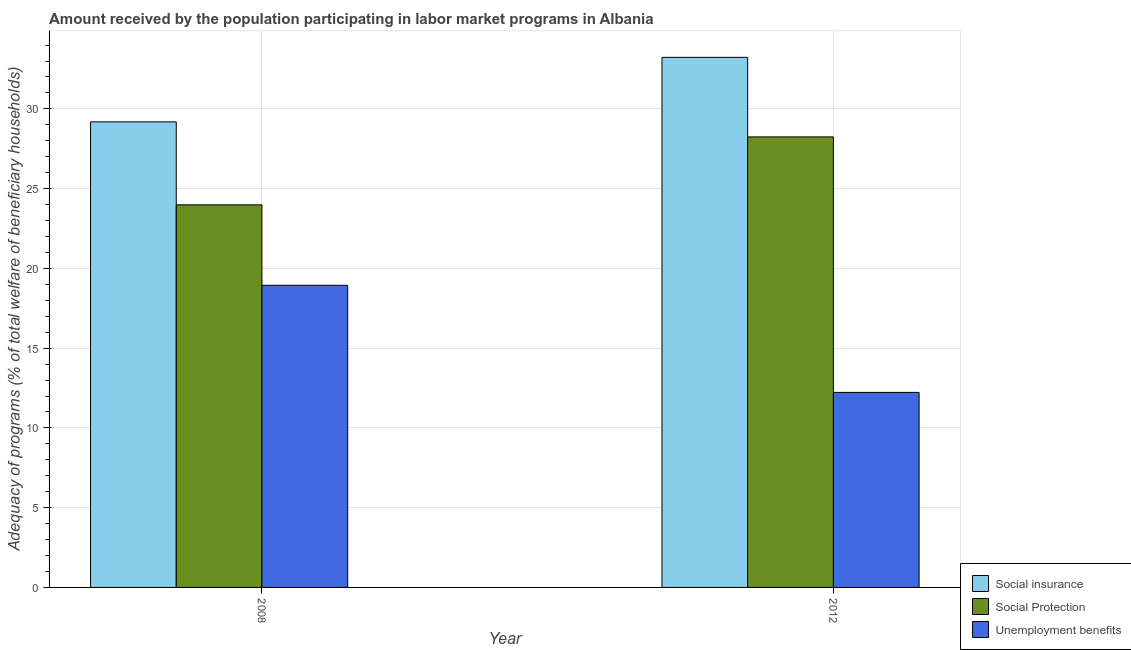How many groups of bars are there?
Provide a short and direct response. 2. Are the number of bars per tick equal to the number of legend labels?
Your answer should be compact. Yes. Are the number of bars on each tick of the X-axis equal?
Offer a very short reply. Yes. How many bars are there on the 1st tick from the right?
Make the answer very short. 3. What is the label of the 1st group of bars from the left?
Your answer should be very brief. 2008. What is the amount received by the population participating in social insurance programs in 2008?
Make the answer very short. 29.19. Across all years, what is the maximum amount received by the population participating in unemployment benefits programs?
Ensure brevity in your answer.  18.94. Across all years, what is the minimum amount received by the population participating in social insurance programs?
Make the answer very short. 29.19. What is the total amount received by the population participating in social protection programs in the graph?
Provide a short and direct response. 52.23. What is the difference between the amount received by the population participating in unemployment benefits programs in 2008 and that in 2012?
Your response must be concise. 6.71. What is the difference between the amount received by the population participating in social insurance programs in 2008 and the amount received by the population participating in social protection programs in 2012?
Ensure brevity in your answer.  -4.05. What is the average amount received by the population participating in social protection programs per year?
Provide a short and direct response. 26.11. In the year 2008, what is the difference between the amount received by the population participating in social protection programs and amount received by the population participating in unemployment benefits programs?
Ensure brevity in your answer.  0. What is the ratio of the amount received by the population participating in unemployment benefits programs in 2008 to that in 2012?
Offer a terse response. 1.55. Is the amount received by the population participating in social protection programs in 2008 less than that in 2012?
Offer a very short reply. Yes. What does the 2nd bar from the left in 2012 represents?
Give a very brief answer. Social Protection. What does the 2nd bar from the right in 2012 represents?
Your response must be concise. Social Protection. Is it the case that in every year, the sum of the amount received by the population participating in social insurance programs and amount received by the population participating in social protection programs is greater than the amount received by the population participating in unemployment benefits programs?
Provide a succinct answer. Yes. What is the difference between two consecutive major ticks on the Y-axis?
Offer a terse response. 5. Does the graph contain grids?
Offer a terse response. Yes. How are the legend labels stacked?
Offer a very short reply. Vertical. What is the title of the graph?
Offer a very short reply. Amount received by the population participating in labor market programs in Albania. Does "Non-communicable diseases" appear as one of the legend labels in the graph?
Your answer should be very brief. No. What is the label or title of the X-axis?
Provide a short and direct response. Year. What is the label or title of the Y-axis?
Offer a very short reply. Adequacy of programs (% of total welfare of beneficiary households). What is the Adequacy of programs (% of total welfare of beneficiary households) in Social insurance in 2008?
Give a very brief answer. 29.19. What is the Adequacy of programs (% of total welfare of beneficiary households) in Social Protection in 2008?
Your answer should be compact. 23.99. What is the Adequacy of programs (% of total welfare of beneficiary households) in Unemployment benefits in 2008?
Your answer should be very brief. 18.94. What is the Adequacy of programs (% of total welfare of beneficiary households) of Social insurance in 2012?
Offer a terse response. 33.23. What is the Adequacy of programs (% of total welfare of beneficiary households) in Social Protection in 2012?
Make the answer very short. 28.24. What is the Adequacy of programs (% of total welfare of beneficiary households) of Unemployment benefits in 2012?
Keep it short and to the point. 12.23. Across all years, what is the maximum Adequacy of programs (% of total welfare of beneficiary households) in Social insurance?
Offer a terse response. 33.23. Across all years, what is the maximum Adequacy of programs (% of total welfare of beneficiary households) in Social Protection?
Offer a terse response. 28.24. Across all years, what is the maximum Adequacy of programs (% of total welfare of beneficiary households) in Unemployment benefits?
Offer a very short reply. 18.94. Across all years, what is the minimum Adequacy of programs (% of total welfare of beneficiary households) in Social insurance?
Keep it short and to the point. 29.19. Across all years, what is the minimum Adequacy of programs (% of total welfare of beneficiary households) of Social Protection?
Provide a short and direct response. 23.99. Across all years, what is the minimum Adequacy of programs (% of total welfare of beneficiary households) of Unemployment benefits?
Ensure brevity in your answer.  12.23. What is the total Adequacy of programs (% of total welfare of beneficiary households) of Social insurance in the graph?
Your answer should be compact. 62.42. What is the total Adequacy of programs (% of total welfare of beneficiary households) in Social Protection in the graph?
Provide a succinct answer. 52.23. What is the total Adequacy of programs (% of total welfare of beneficiary households) in Unemployment benefits in the graph?
Ensure brevity in your answer.  31.17. What is the difference between the Adequacy of programs (% of total welfare of beneficiary households) of Social insurance in 2008 and that in 2012?
Your response must be concise. -4.05. What is the difference between the Adequacy of programs (% of total welfare of beneficiary households) in Social Protection in 2008 and that in 2012?
Your response must be concise. -4.26. What is the difference between the Adequacy of programs (% of total welfare of beneficiary households) in Unemployment benefits in 2008 and that in 2012?
Ensure brevity in your answer.  6.71. What is the difference between the Adequacy of programs (% of total welfare of beneficiary households) in Social insurance in 2008 and the Adequacy of programs (% of total welfare of beneficiary households) in Social Protection in 2012?
Keep it short and to the point. 0.94. What is the difference between the Adequacy of programs (% of total welfare of beneficiary households) of Social insurance in 2008 and the Adequacy of programs (% of total welfare of beneficiary households) of Unemployment benefits in 2012?
Give a very brief answer. 16.96. What is the difference between the Adequacy of programs (% of total welfare of beneficiary households) of Social Protection in 2008 and the Adequacy of programs (% of total welfare of beneficiary households) of Unemployment benefits in 2012?
Your response must be concise. 11.76. What is the average Adequacy of programs (% of total welfare of beneficiary households) of Social insurance per year?
Your answer should be compact. 31.21. What is the average Adequacy of programs (% of total welfare of beneficiary households) of Social Protection per year?
Your answer should be compact. 26.11. What is the average Adequacy of programs (% of total welfare of beneficiary households) in Unemployment benefits per year?
Your answer should be very brief. 15.58. In the year 2008, what is the difference between the Adequacy of programs (% of total welfare of beneficiary households) in Social insurance and Adequacy of programs (% of total welfare of beneficiary households) in Social Protection?
Make the answer very short. 5.2. In the year 2008, what is the difference between the Adequacy of programs (% of total welfare of beneficiary households) in Social insurance and Adequacy of programs (% of total welfare of beneficiary households) in Unemployment benefits?
Offer a very short reply. 10.24. In the year 2008, what is the difference between the Adequacy of programs (% of total welfare of beneficiary households) of Social Protection and Adequacy of programs (% of total welfare of beneficiary households) of Unemployment benefits?
Offer a very short reply. 5.04. In the year 2012, what is the difference between the Adequacy of programs (% of total welfare of beneficiary households) of Social insurance and Adequacy of programs (% of total welfare of beneficiary households) of Social Protection?
Make the answer very short. 4.99. In the year 2012, what is the difference between the Adequacy of programs (% of total welfare of beneficiary households) in Social insurance and Adequacy of programs (% of total welfare of beneficiary households) in Unemployment benefits?
Ensure brevity in your answer.  21.01. In the year 2012, what is the difference between the Adequacy of programs (% of total welfare of beneficiary households) of Social Protection and Adequacy of programs (% of total welfare of beneficiary households) of Unemployment benefits?
Your answer should be compact. 16.02. What is the ratio of the Adequacy of programs (% of total welfare of beneficiary households) in Social insurance in 2008 to that in 2012?
Your answer should be very brief. 0.88. What is the ratio of the Adequacy of programs (% of total welfare of beneficiary households) in Social Protection in 2008 to that in 2012?
Ensure brevity in your answer.  0.85. What is the ratio of the Adequacy of programs (% of total welfare of beneficiary households) in Unemployment benefits in 2008 to that in 2012?
Provide a succinct answer. 1.55. What is the difference between the highest and the second highest Adequacy of programs (% of total welfare of beneficiary households) of Social insurance?
Keep it short and to the point. 4.05. What is the difference between the highest and the second highest Adequacy of programs (% of total welfare of beneficiary households) of Social Protection?
Give a very brief answer. 4.26. What is the difference between the highest and the second highest Adequacy of programs (% of total welfare of beneficiary households) of Unemployment benefits?
Give a very brief answer. 6.71. What is the difference between the highest and the lowest Adequacy of programs (% of total welfare of beneficiary households) of Social insurance?
Provide a succinct answer. 4.05. What is the difference between the highest and the lowest Adequacy of programs (% of total welfare of beneficiary households) in Social Protection?
Make the answer very short. 4.26. What is the difference between the highest and the lowest Adequacy of programs (% of total welfare of beneficiary households) of Unemployment benefits?
Offer a very short reply. 6.71. 